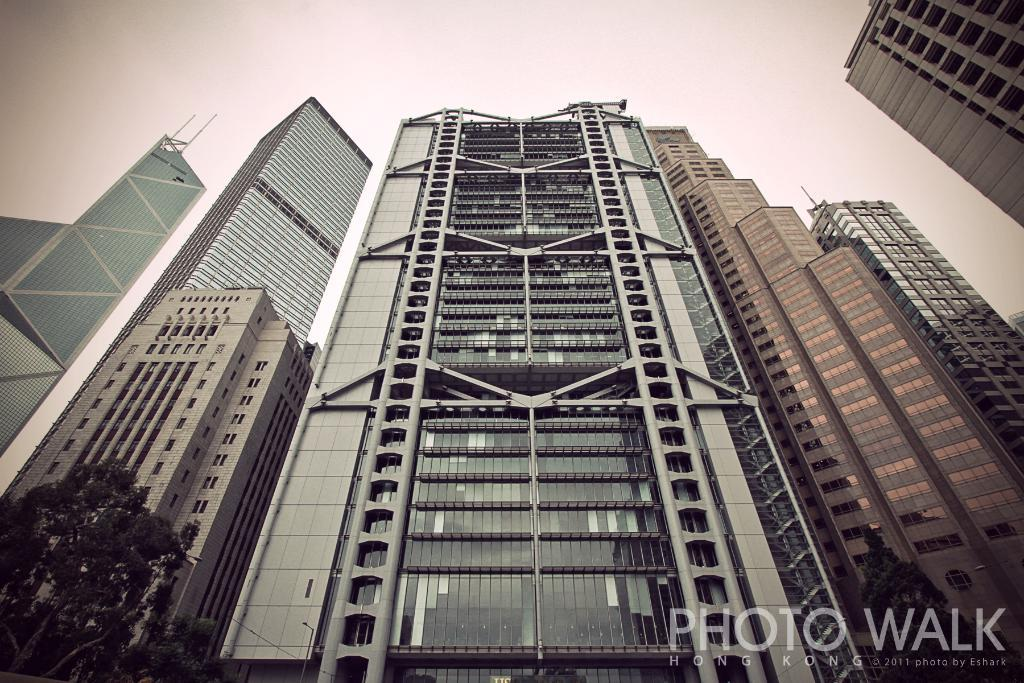What type of structures are visible in the image? There are buildings with windows in the image. What other elements can be seen in the image besides the buildings? There are trees and the sky visible in the image. Where is the text located in the image? The text is on the right bottom of the image. What type of steel is used to construct the playground in the image? There is no playground present in the image, so it is not possible to determine the type of steel used in its construction. 